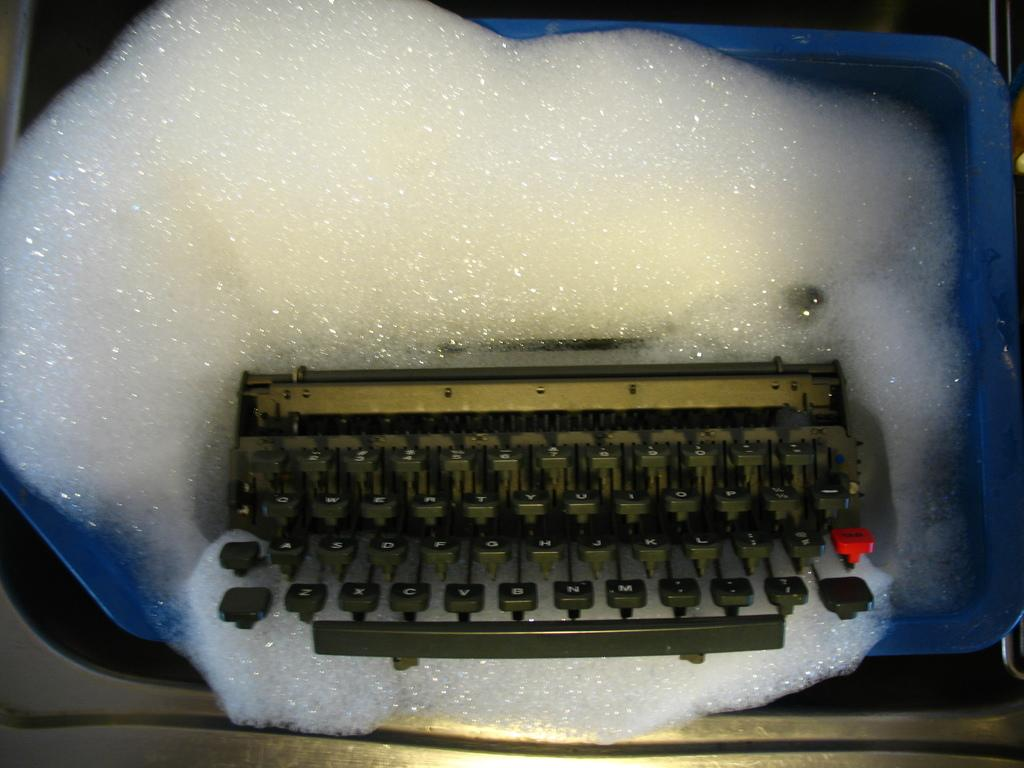<image>
Give a short and clear explanation of the subsequent image. A keyboard taking a bath and missing "#1" on the keys. 